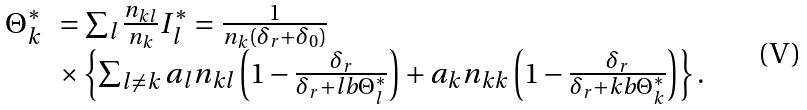Convert formula to latex. <formula><loc_0><loc_0><loc_500><loc_500>\begin{array} { l l } \Theta _ { k } ^ { * } & = \sum _ { l } \frac { n _ { k l } } { n _ { k } } I _ { l } ^ { * } = \frac { 1 } { n _ { k } ( \delta _ { r } + \delta _ { 0 } ) } \\ & \times \left \{ \sum _ { l \neq k } a _ { l } n _ { k l } \left ( 1 - \frac { \delta _ { r } } { \delta _ { r } + l b \Theta _ { l } ^ { * } } \right ) + a _ { k } n _ { k k } \left ( 1 - \frac { \delta _ { r } } { \delta _ { r } + k b \Theta _ { k } ^ { * } } \right ) \right \} . \end{array}</formula> 